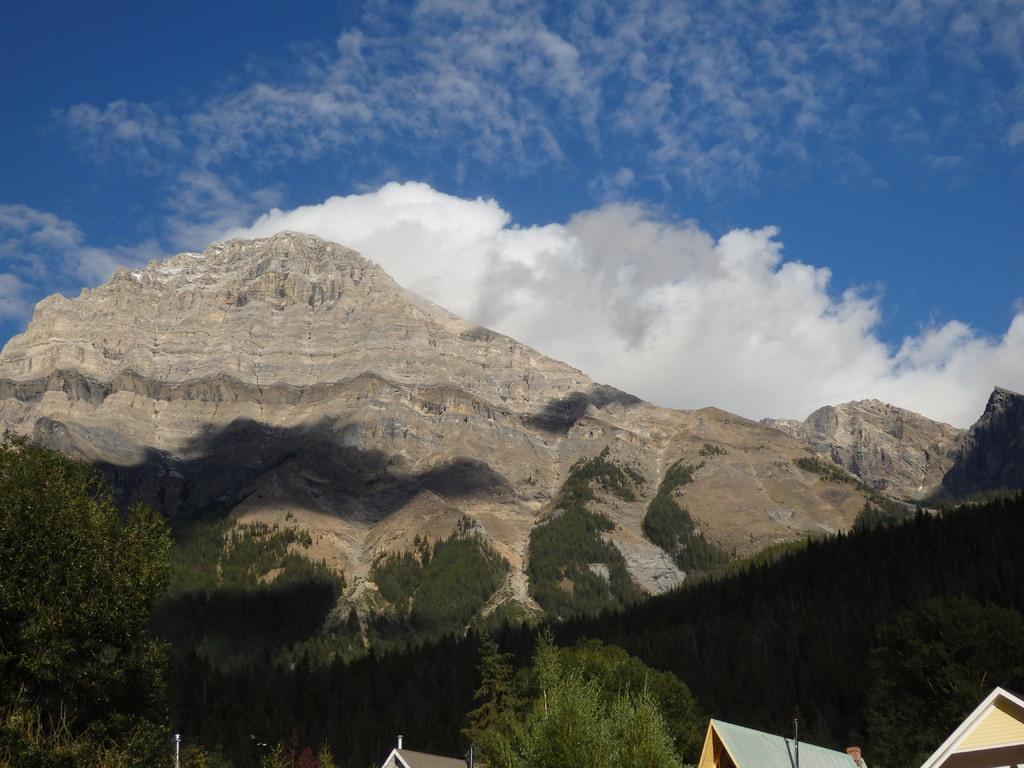How would you summarize this image in a sentence or two? We can see trees,hills and rooftops. In the background we can see sky with clouds. 